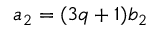<formula> <loc_0><loc_0><loc_500><loc_500>a _ { 2 } = ( 3 q + 1 ) b _ { 2 }</formula> 